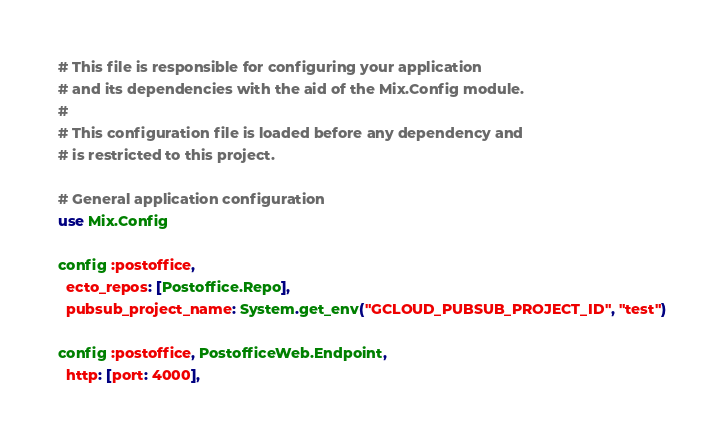<code> <loc_0><loc_0><loc_500><loc_500><_Elixir_># This file is responsible for configuring your application
# and its dependencies with the aid of the Mix.Config module.
#
# This configuration file is loaded before any dependency and
# is restricted to this project.

# General application configuration
use Mix.Config

config :postoffice,
  ecto_repos: [Postoffice.Repo],
  pubsub_project_name: System.get_env("GCLOUD_PUBSUB_PROJECT_ID", "test")

config :postoffice, PostofficeWeb.Endpoint,
  http: [port: 4000],</code> 